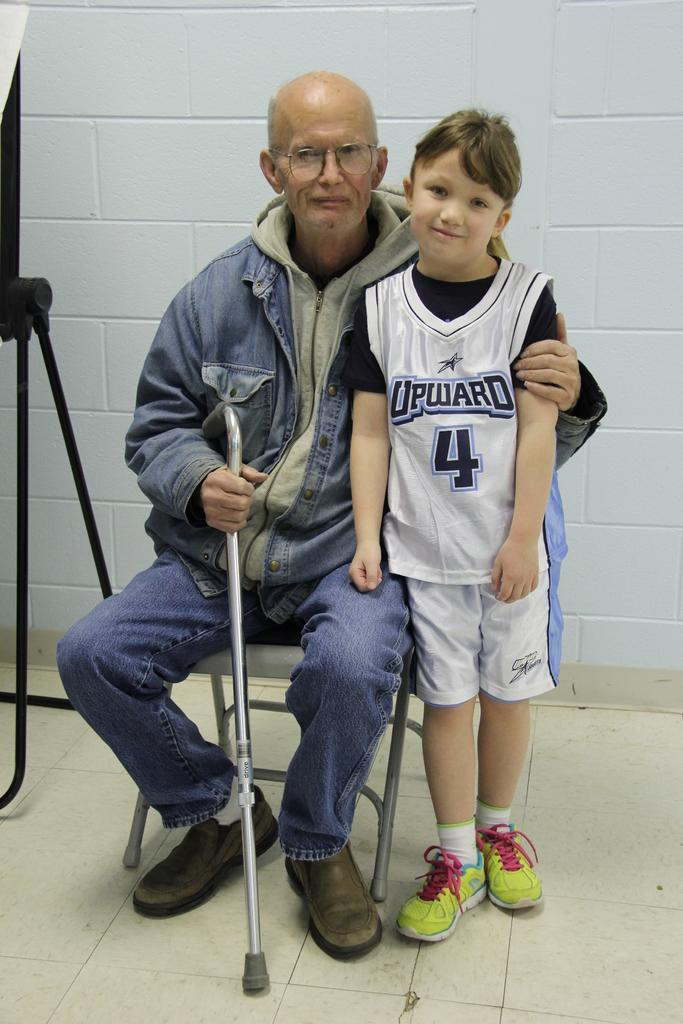<image>
Summarize the visual content of the image. A kid wearing a basketball shirt that says UPWARD with the number 4 on it. 